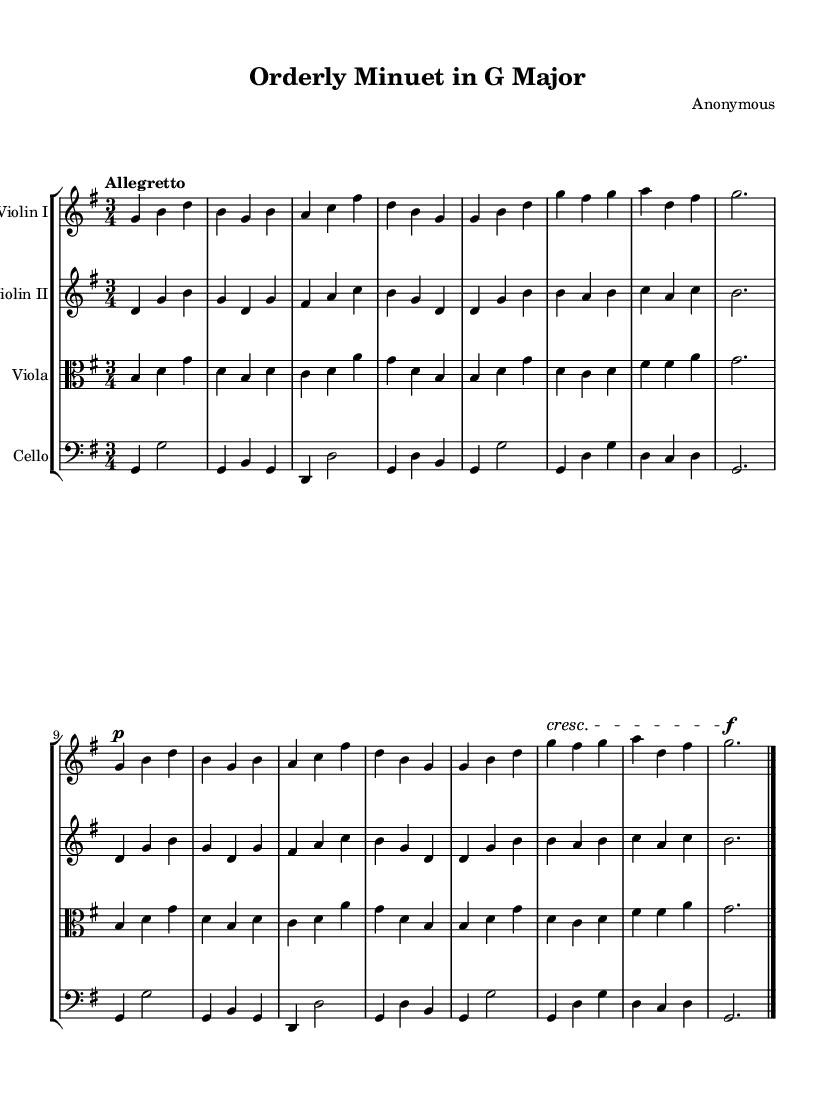What is the key signature of this piece? The key signature shows one sharp, indicating that the music is in G major.
Answer: G major What is the time signature? The time signature appears as a fraction at the beginning of the score, indicating a 3/4 meter, which means there are three beats in each measure.
Answer: 3/4 What is the tempo marking? The tempo marking indicates the speed of the piece; "Allegretto" suggests a moderately fast pace, typically around 98 to 109 beats per minute.
Answer: Allegretto How many parts are there in this chamber music? The score includes four staves corresponding to four instruments: Violin I, Violin II, Viola, and Cello. Thus, there are four parts in total.
Answer: Four Which instrument is playing the melody in the first section? The melody in the first section is primarily played by Violin I, which often carries the leading voice in chamber music.
Answer: Violin I What musical form is primarily used in this piece? The piece follows the minuet and trio form, which is common in classical chamber music, characterized by a dance-like section followed by a contrasting trio.
Answer: Minuet and trio What dynamic marking is noted in the score? The dynamic marking indicates the intended volume of the music; the piece starts with a piano (soft) marking, suggesting a gentle entrance.
Answer: Piano 